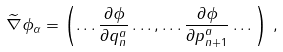Convert formula to latex. <formula><loc_0><loc_0><loc_500><loc_500>\widetilde { \nabla } \phi _ { \alpha } = \left ( \dots \frac { \partial \phi } { \partial q ^ { a } _ { n } } \dots , \dots \frac { \partial \phi } { \partial p ^ { a } _ { n + 1 } } \dots \right ) \, ,</formula> 